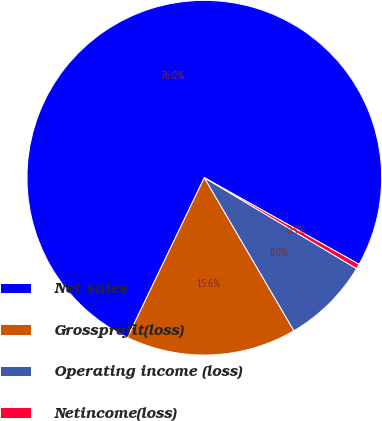Convert chart. <chart><loc_0><loc_0><loc_500><loc_500><pie_chart><fcel>Net sales<fcel>Grossprofit(loss)<fcel>Operating income (loss)<fcel>Netincome(loss)<nl><fcel>75.99%<fcel>15.56%<fcel>8.0%<fcel>0.45%<nl></chart> 